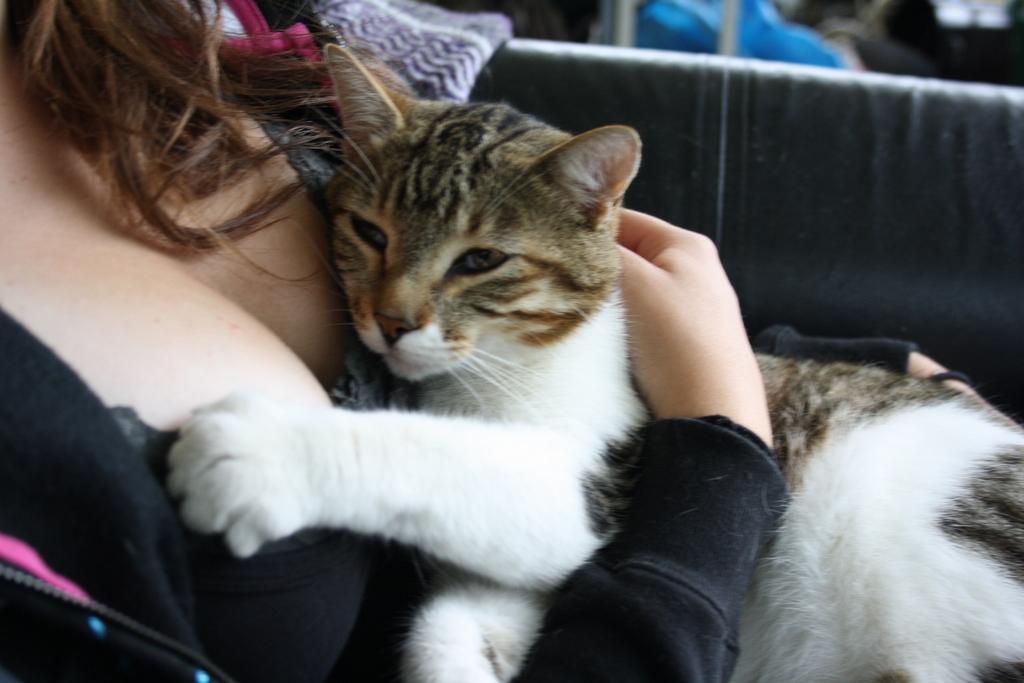Please provide a concise description of this image. In this picture there is a woman sitting and holding a cat in her hands 